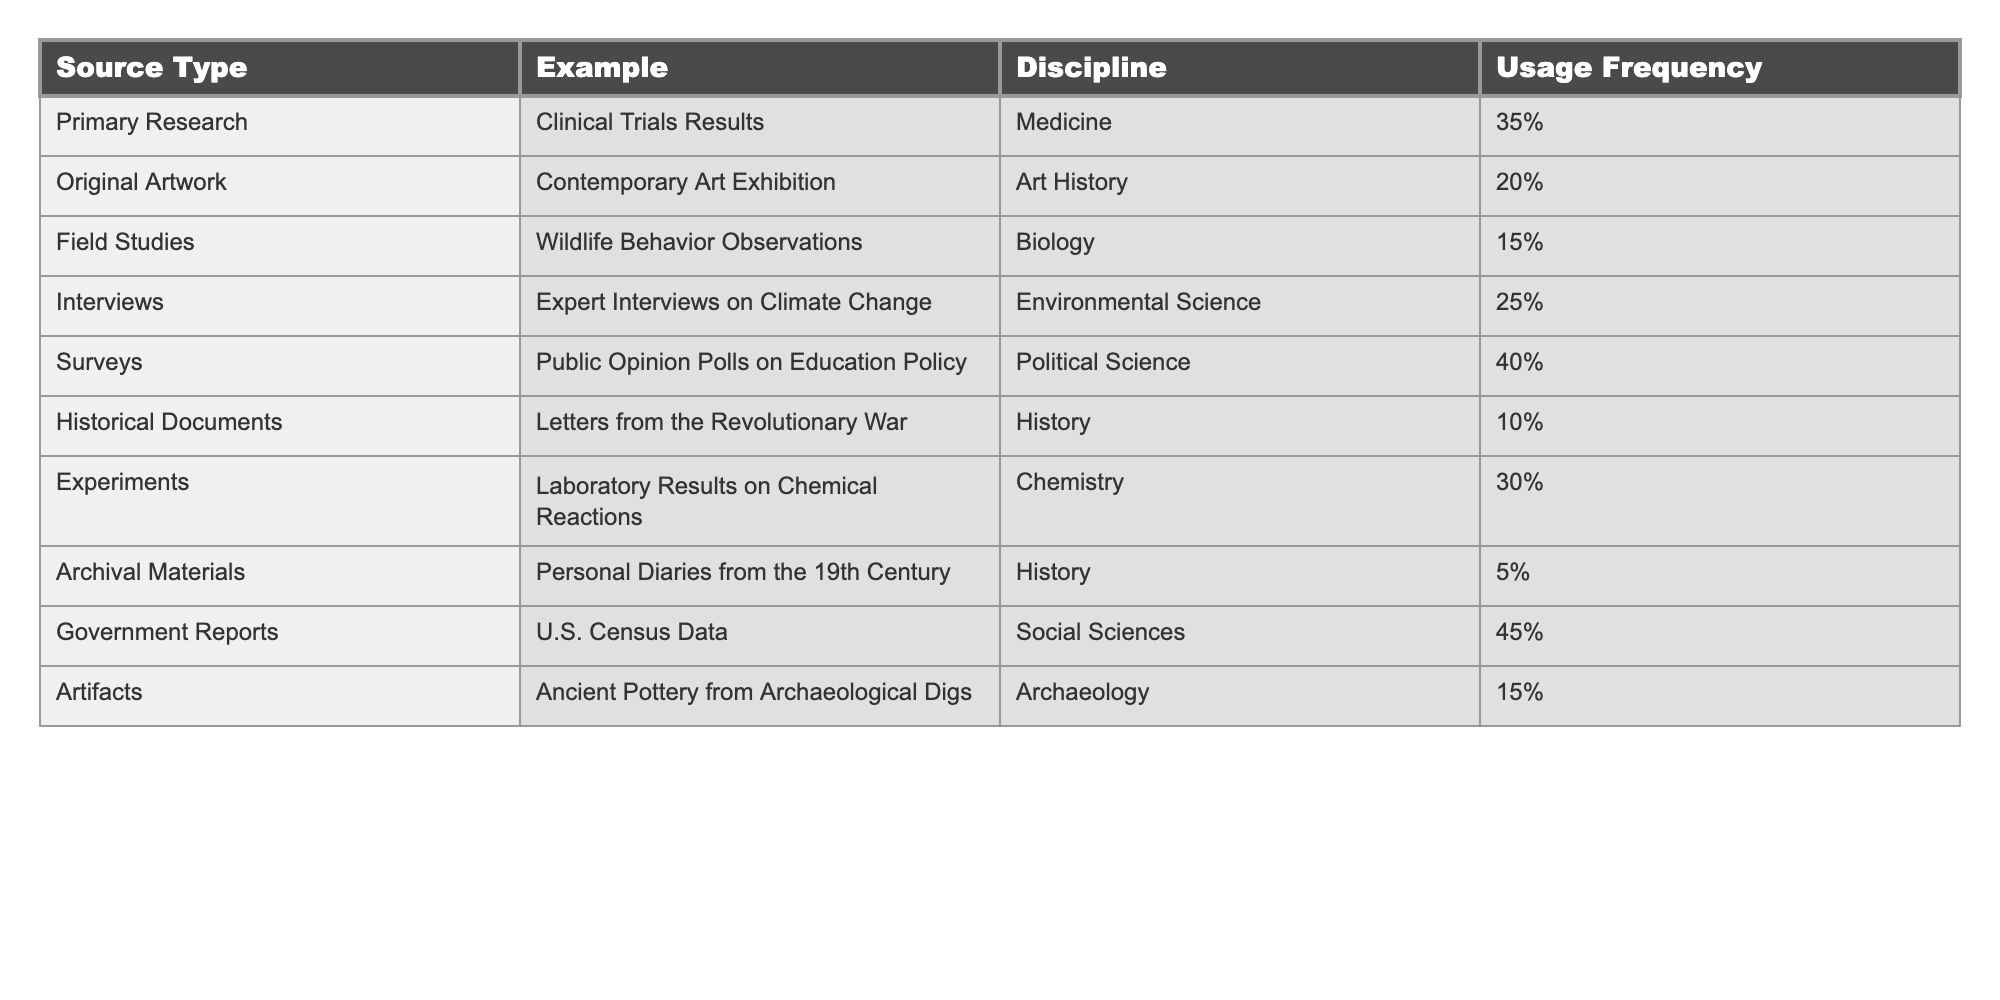What type of primary source has the highest usage frequency in doctoral dissertations? The table lists usage frequencies for each source type. By reviewing the "Usage Frequency" column, we can see that Government Reports have the highest frequency at 45%.
Answer: Government Reports Which discipline uses surveys most frequently? The table shows that surveys have a usage frequency of 40% specifically in the Political Science discipline, which is the highest frequency in that category.
Answer: Political Science What is the usage frequency of archival materials? Looking at the "Usage Frequency" column in the table, archival materials have a frequency of 5%, which is a specific value mentioned directly in the table.
Answer: 5% How do the usage frequencies of primary research and experiments compare? By referring to the respective frequencies, we see Primary Research has a frequency of 35% and Experiments have 30%. The difference between them is 5%, indicating that Primary Research is used more.
Answer: Primary Research is used 5% more What is the total usage frequency for the categories that have a frequency of 15%? By identifying the categories with 15% usage (Field Studies and Artifacts), we can sum their frequencies: 15% + 15% = 30%. Thus, the total frequency for these categories is 30%.
Answer: 30% Is the usage frequency of interviews higher than that of historical documents? Interviews have a frequency of 25% while historical documents have a frequency of 10%. Since 25% is greater than 10%, this indicates that interviews are indeed used more frequently.
Answer: Yes What is the average usage frequency of the four disciplines with the lowest frequencies? The lowest frequencies are for Historical Documents (10%), Archival Materials (5%), Artifacts (15%), and Primary Research (35%). Adding these gives us 10 + 5 + 15 + 35 = 65. There are 4 disciplines, so the average is 65 / 4 = 16.25%.
Answer: 16.25% In which discipline are experimental results most frequently used? Referring to the table, experiments in Chemistry have a frequency of 30%. Among all disciplines listed, this is the only mention of experimental results, making this the most frequent application.
Answer: Chemistry How many more percent do government reports exceed the usage frequency of original artworks? Government Reports have a frequency of 45% and Original Artwork has 20%. To find the difference, subtract 20% from 45% which gives us 25%.
Answer: 25% What is the frequency of primary sources in medicine compared to art history? In the table, Primary Research under Medicine has a frequency of 35%, while Original Artwork under Art History has a frequency of 20%. Comparing these shows that primary sources in medicine are used more frequently, specifically by 15%.
Answer: 15% more for medicine 